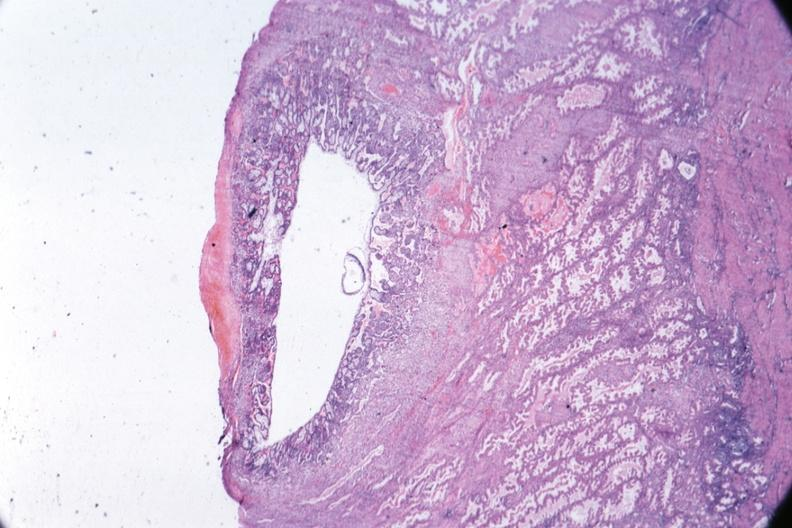s opened uterus and cervix with large cervical myoma protruding into vagina slide present?
Answer the question using a single word or phrase. No 